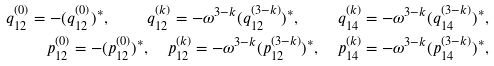<formula> <loc_0><loc_0><loc_500><loc_500>q _ { 1 2 } ^ { ( 0 ) } = - ( q ^ { ( 0 ) } _ { 1 2 } ) ^ { * } , \quad q _ { 1 2 } ^ { ( k ) } = - \omega ^ { 3 - k } ( q ^ { ( 3 - k ) } _ { 1 2 } ) ^ { * } , \quad q _ { 1 4 } ^ { ( k ) } = - \omega ^ { 3 - k } ( q ^ { ( 3 - k ) } _ { 1 4 } ) ^ { * } , \\ p _ { 1 2 } ^ { ( 0 ) } = - ( p ^ { ( 0 ) } _ { 1 2 } ) ^ { * } , \quad p _ { 1 2 } ^ { ( k ) } = - \omega ^ { 3 - k } ( p ^ { ( 3 - k ) } _ { 1 2 } ) ^ { * } , \quad p _ { 1 4 } ^ { ( k ) } = - \omega ^ { 3 - k } ( p ^ { ( 3 - k ) } _ { 1 4 } ) ^ { * } ,</formula> 